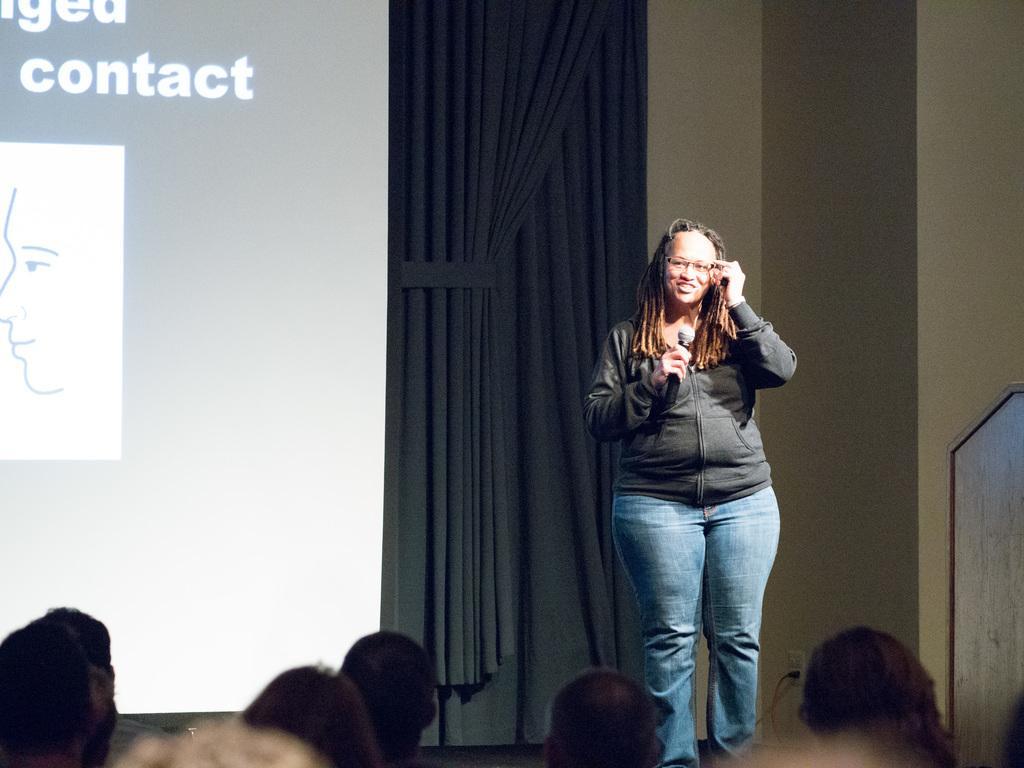Could you give a brief overview of what you see in this image? This picture describes about group of people, on the right side of the image we can see a woman, she is smiling and she is holding a microphone, behind to her we can see curtains and projector screen. 